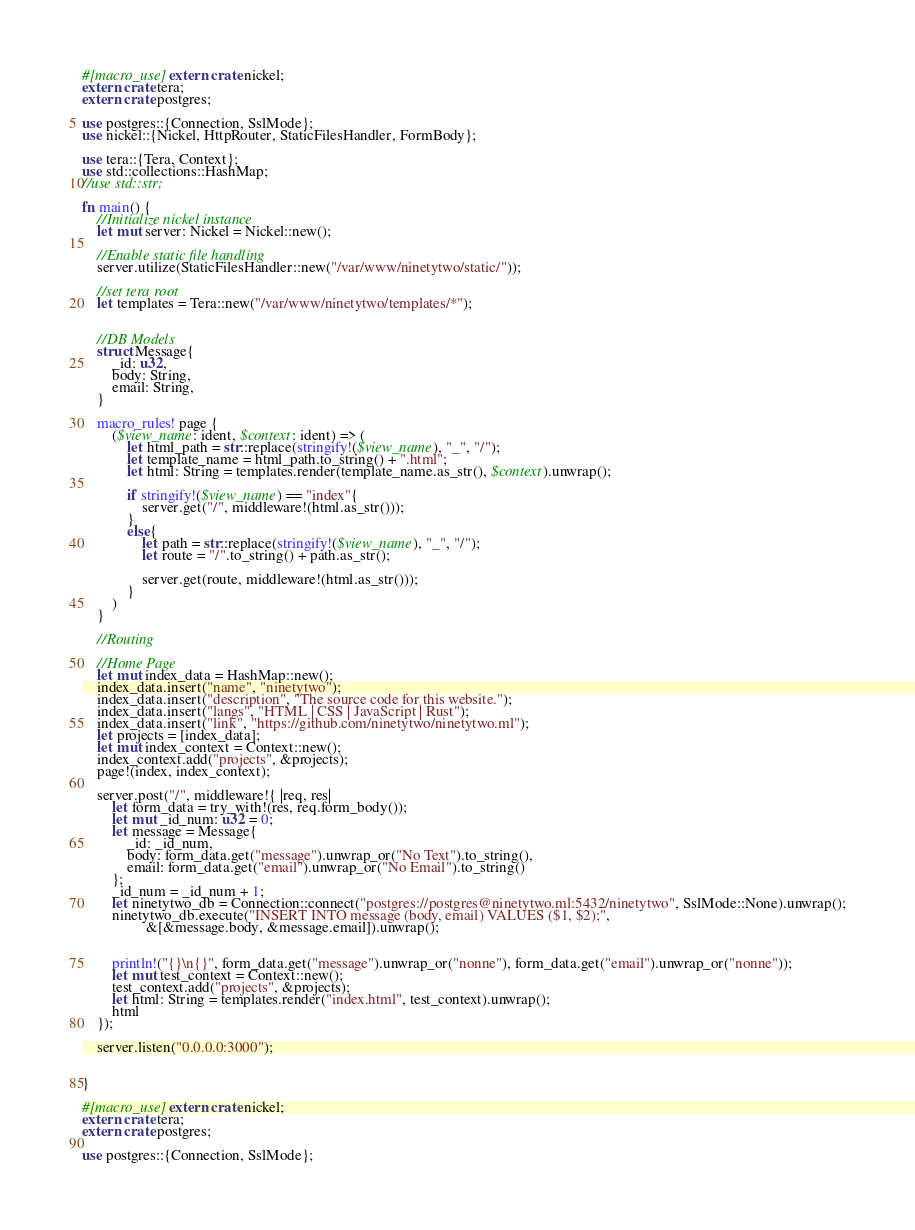<code> <loc_0><loc_0><loc_500><loc_500><_Rust_>#[macro_use] extern crate nickel;
extern crate tera;
extern crate postgres;

use postgres::{Connection, SslMode};
use nickel::{Nickel, HttpRouter, StaticFilesHandler, FormBody};

use tera::{Tera, Context};
use std::collections::HashMap;
//use std::str;

fn main() {
    //Initialize nickel instance
    let mut server: Nickel = Nickel::new();

    //Enable static file handling
    server.utilize(StaticFilesHandler::new("/var/www/ninetytwo/static/"));

    //set tera root
    let templates = Tera::new("/var/www/ninetytwo/templates/*");


    //DB Models
    struct Message{
        _id: u32,
        body: String,
        email: String,
    }

    macro_rules! page {
        ($view_name: ident, $context: ident) => (
            let html_path = str::replace(stringify!($view_name), "_", "/");
            let template_name = html_path.to_string() + ".html";
            let html: String = templates.render(template_name.as_str(), $context).unwrap();

            if stringify!($view_name) == "index"{
                server.get("/", middleware!(html.as_str()));
            }
            else{
                let path = str::replace(stringify!($view_name), "_", "/");
                let route = "/".to_string() + path.as_str();

                server.get(route, middleware!(html.as_str()));
            }
        )
    }

    //Routing

    //Home Page
    let mut index_data = HashMap::new();
    index_data.insert("name", "ninetytwo");
    index_data.insert("description", "The source code for this website.");
    index_data.insert("langs", "HTML | CSS | JavaScript | Rust");
    index_data.insert("link", "https://github.com/ninetytwo/ninetytwo.ml");
    let projects = [index_data];
    let mut index_context = Context::new();
    index_context.add("projects", &projects);
    page!(index, index_context);

    server.post("/", middleware!{ |req, res|
        let form_data = try_with!(res, req.form_body());
        let mut _id_num: u32 = 0;
        let message = Message{
            _id: _id_num,
            body: form_data.get("message").unwrap_or("No Text").to_string(),
            email: form_data.get("email").unwrap_or("No Email").to_string()
        };
        _id_num = _id_num + 1;
        let ninetytwo_db = Connection::connect("postgres://postgres@ninetytwo.ml:5432/ninetytwo", SslMode::None).unwrap();
        ninetytwo_db.execute("INSERT INTO message (body, email) VALUES ($1, $2);",
                 &[&message.body, &message.email]).unwrap();


        println!("{}\n{}", form_data.get("message").unwrap_or("nonne"), form_data.get("email").unwrap_or("nonne"));
        let mut test_context = Context::new();
        test_context.add("projects", &projects);
        let html: String = templates.render("index.html", test_context).unwrap();
        html
    });

    server.listen("0.0.0.0:3000");


}

#[macro_use] extern crate nickel;
extern crate tera;
extern crate postgres;

use postgres::{Connection, SslMode};</code> 